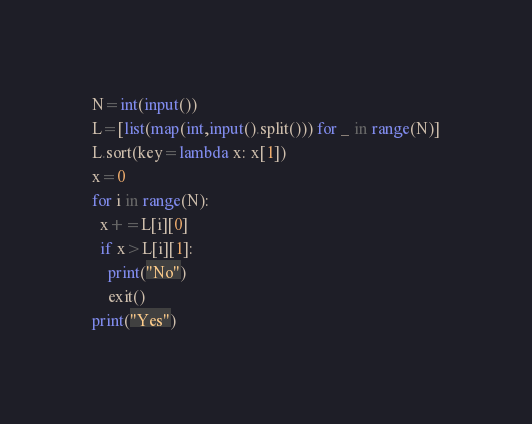Convert code to text. <code><loc_0><loc_0><loc_500><loc_500><_Python_>N=int(input())
L=[list(map(int,input().split())) for _ in range(N)]
L.sort(key=lambda x: x[1])
x=0
for i in range(N):
  x+=L[i][0]
  if x>L[i][1]:
    print("No")
    exit()
print("Yes")</code> 